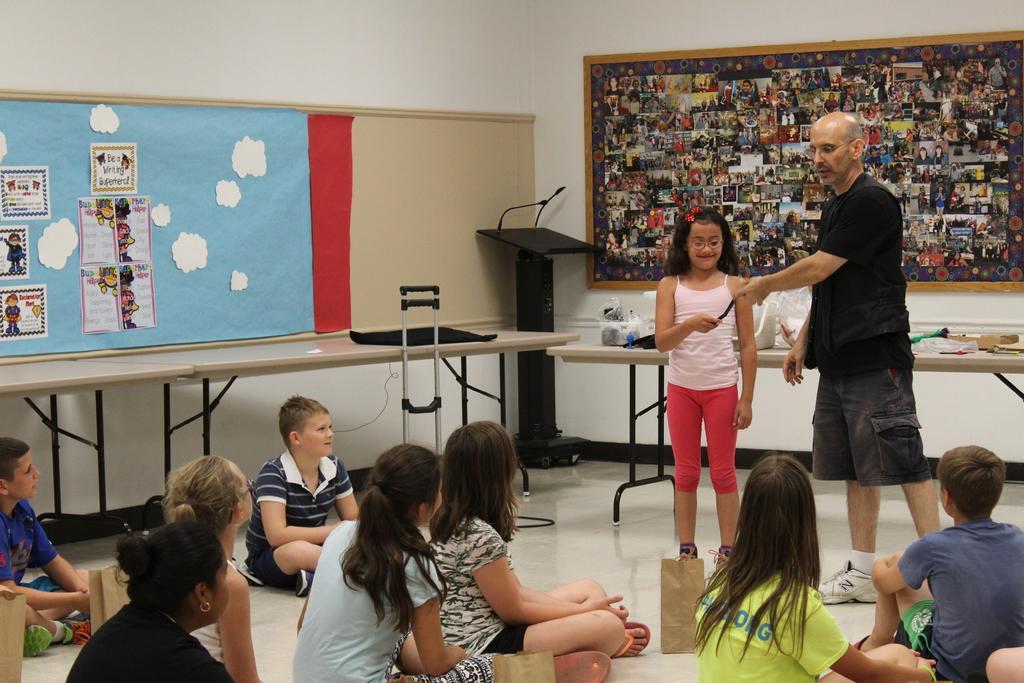Can you describe this image briefly? In the foreground of this image, at the bottom, there are people sitting on the floor and there are bags in front of them. On the right, there is a man standing, beside him, there is a girl standing and holding a black color object. In the background, there are few objects on the tables and few boards on the wall. 